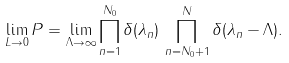<formula> <loc_0><loc_0><loc_500><loc_500>\lim _ { L \rightarrow 0 } P = \lim _ { \Lambda \rightarrow \infty } \prod _ { n = 1 } ^ { N _ { 0 } } \delta ( \lambda _ { n } ) \, \prod _ { n = N _ { 0 } + 1 } ^ { N } \delta ( \lambda _ { n } - \Lambda ) .</formula> 